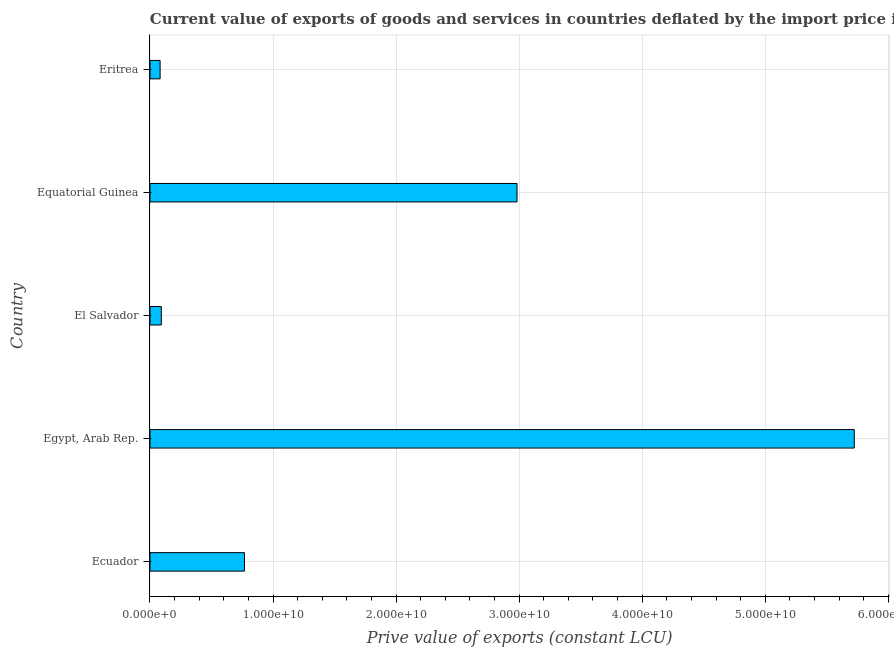Does the graph contain any zero values?
Provide a short and direct response. No. What is the title of the graph?
Provide a succinct answer. Current value of exports of goods and services in countries deflated by the import price index. What is the label or title of the X-axis?
Provide a succinct answer. Prive value of exports (constant LCU). What is the label or title of the Y-axis?
Your answer should be very brief. Country. What is the price value of exports in El Salvador?
Offer a very short reply. 9.20e+08. Across all countries, what is the maximum price value of exports?
Your answer should be compact. 5.72e+1. Across all countries, what is the minimum price value of exports?
Offer a terse response. 8.23e+08. In which country was the price value of exports maximum?
Ensure brevity in your answer.  Egypt, Arab Rep. In which country was the price value of exports minimum?
Provide a short and direct response. Eritrea. What is the sum of the price value of exports?
Your answer should be very brief. 9.65e+1. What is the difference between the price value of exports in Ecuador and El Salvador?
Offer a terse response. 6.76e+09. What is the average price value of exports per country?
Provide a succinct answer. 1.93e+1. What is the median price value of exports?
Your answer should be very brief. 7.68e+09. In how many countries, is the price value of exports greater than 34000000000 LCU?
Your answer should be very brief. 1. What is the ratio of the price value of exports in Ecuador to that in Egypt, Arab Rep.?
Your response must be concise. 0.13. What is the difference between the highest and the second highest price value of exports?
Your answer should be very brief. 2.74e+1. Is the sum of the price value of exports in Egypt, Arab Rep. and Equatorial Guinea greater than the maximum price value of exports across all countries?
Your answer should be compact. Yes. What is the difference between the highest and the lowest price value of exports?
Offer a very short reply. 5.64e+1. How many countries are there in the graph?
Provide a succinct answer. 5. What is the Prive value of exports (constant LCU) of Ecuador?
Offer a very short reply. 7.68e+09. What is the Prive value of exports (constant LCU) of Egypt, Arab Rep.?
Offer a very short reply. 5.72e+1. What is the Prive value of exports (constant LCU) of El Salvador?
Provide a succinct answer. 9.20e+08. What is the Prive value of exports (constant LCU) of Equatorial Guinea?
Your answer should be compact. 2.98e+1. What is the Prive value of exports (constant LCU) in Eritrea?
Offer a terse response. 8.23e+08. What is the difference between the Prive value of exports (constant LCU) in Ecuador and Egypt, Arab Rep.?
Offer a very short reply. -4.96e+1. What is the difference between the Prive value of exports (constant LCU) in Ecuador and El Salvador?
Make the answer very short. 6.76e+09. What is the difference between the Prive value of exports (constant LCU) in Ecuador and Equatorial Guinea?
Offer a very short reply. -2.21e+1. What is the difference between the Prive value of exports (constant LCU) in Ecuador and Eritrea?
Offer a very short reply. 6.86e+09. What is the difference between the Prive value of exports (constant LCU) in Egypt, Arab Rep. and El Salvador?
Your answer should be very brief. 5.63e+1. What is the difference between the Prive value of exports (constant LCU) in Egypt, Arab Rep. and Equatorial Guinea?
Give a very brief answer. 2.74e+1. What is the difference between the Prive value of exports (constant LCU) in Egypt, Arab Rep. and Eritrea?
Your response must be concise. 5.64e+1. What is the difference between the Prive value of exports (constant LCU) in El Salvador and Equatorial Guinea?
Your answer should be compact. -2.89e+1. What is the difference between the Prive value of exports (constant LCU) in El Salvador and Eritrea?
Keep it short and to the point. 9.68e+07. What is the difference between the Prive value of exports (constant LCU) in Equatorial Guinea and Eritrea?
Your answer should be compact. 2.90e+1. What is the ratio of the Prive value of exports (constant LCU) in Ecuador to that in Egypt, Arab Rep.?
Your response must be concise. 0.13. What is the ratio of the Prive value of exports (constant LCU) in Ecuador to that in El Salvador?
Make the answer very short. 8.35. What is the ratio of the Prive value of exports (constant LCU) in Ecuador to that in Equatorial Guinea?
Your answer should be compact. 0.26. What is the ratio of the Prive value of exports (constant LCU) in Ecuador to that in Eritrea?
Your answer should be very brief. 9.33. What is the ratio of the Prive value of exports (constant LCU) in Egypt, Arab Rep. to that in El Salvador?
Give a very brief answer. 62.22. What is the ratio of the Prive value of exports (constant LCU) in Egypt, Arab Rep. to that in Equatorial Guinea?
Offer a very short reply. 1.92. What is the ratio of the Prive value of exports (constant LCU) in Egypt, Arab Rep. to that in Eritrea?
Your answer should be very brief. 69.54. What is the ratio of the Prive value of exports (constant LCU) in El Salvador to that in Equatorial Guinea?
Provide a succinct answer. 0.03. What is the ratio of the Prive value of exports (constant LCU) in El Salvador to that in Eritrea?
Make the answer very short. 1.12. What is the ratio of the Prive value of exports (constant LCU) in Equatorial Guinea to that in Eritrea?
Your answer should be compact. 36.24. 